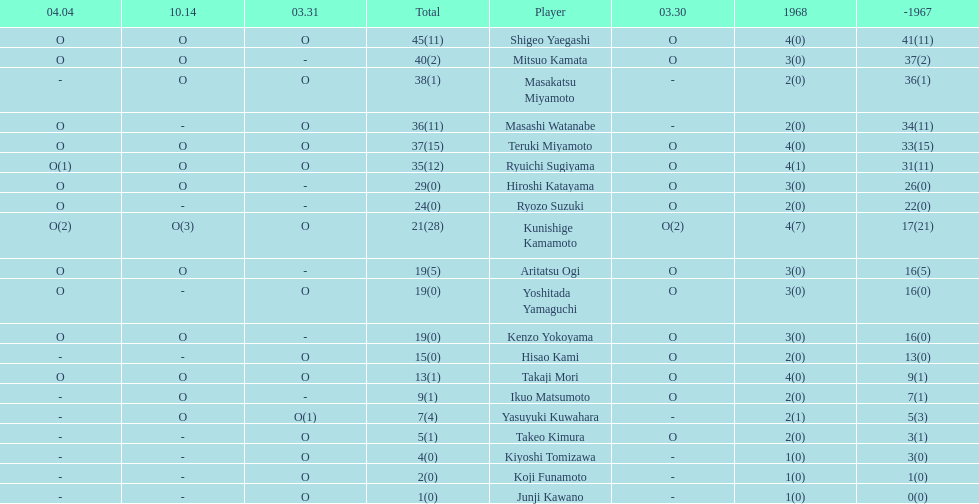Parse the table in full. {'header': ['04.04', '10.14', '03.31', 'Total', 'Player', '03.30', '1968', '-1967'], 'rows': [['O', 'O', 'O', '45(11)', 'Shigeo Yaegashi', 'O', '4(0)', '41(11)'], ['O', 'O', '-', '40(2)', 'Mitsuo Kamata', 'O', '3(0)', '37(2)'], ['-', 'O', 'O', '38(1)', 'Masakatsu Miyamoto', '-', '2(0)', '36(1)'], ['O', '-', 'O', '36(11)', 'Masashi Watanabe', '-', '2(0)', '34(11)'], ['O', 'O', 'O', '37(15)', 'Teruki Miyamoto', 'O', '4(0)', '33(15)'], ['O(1)', 'O', 'O', '35(12)', 'Ryuichi Sugiyama', 'O', '4(1)', '31(11)'], ['O', 'O', '-', '29(0)', 'Hiroshi Katayama', 'O', '3(0)', '26(0)'], ['O', '-', '-', '24(0)', 'Ryozo Suzuki', 'O', '2(0)', '22(0)'], ['O(2)', 'O(3)', 'O', '21(28)', 'Kunishige Kamamoto', 'O(2)', '4(7)', '17(21)'], ['O', 'O', '-', '19(5)', 'Aritatsu Ogi', 'O', '3(0)', '16(5)'], ['O', '-', 'O', '19(0)', 'Yoshitada Yamaguchi', 'O', '3(0)', '16(0)'], ['O', 'O', '-', '19(0)', 'Kenzo Yokoyama', 'O', '3(0)', '16(0)'], ['-', '-', 'O', '15(0)', 'Hisao Kami', 'O', '2(0)', '13(0)'], ['O', 'O', 'O', '13(1)', 'Takaji Mori', 'O', '4(0)', '9(1)'], ['-', 'O', '-', '9(1)', 'Ikuo Matsumoto', 'O', '2(0)', '7(1)'], ['-', 'O', 'O(1)', '7(4)', 'Yasuyuki Kuwahara', '-', '2(1)', '5(3)'], ['-', '-', 'O', '5(1)', 'Takeo Kimura', 'O', '2(0)', '3(1)'], ['-', '-', 'O', '4(0)', 'Kiyoshi Tomizawa', '-', '1(0)', '3(0)'], ['-', '-', 'O', '2(0)', 'Koji Funamoto', '-', '1(0)', '1(0)'], ['-', '-', 'O', '1(0)', 'Junji Kawano', '-', '1(0)', '0(0)']]} How many total did mitsuo kamata have? 40(2). 